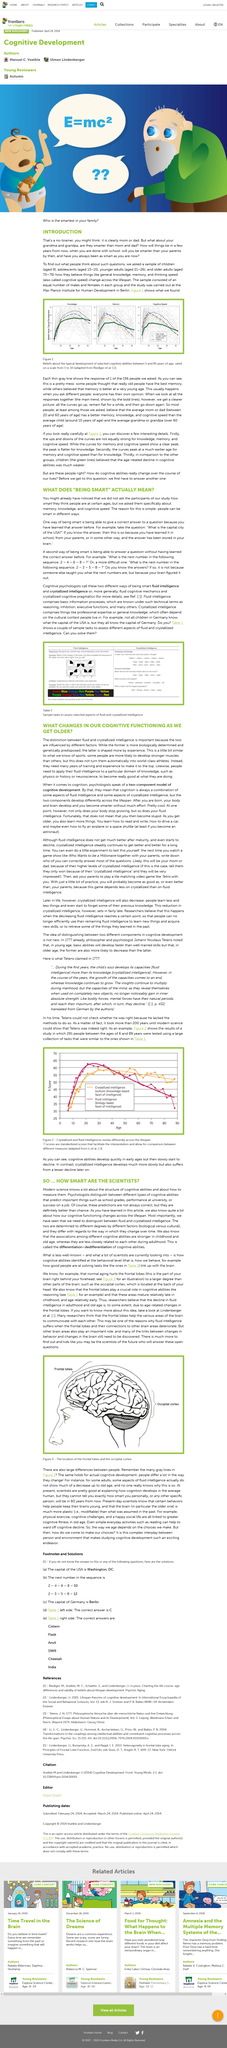Specify some key components in this picture. The main heading in caps lock is called INTRODUCTION. The T-score measures the level of fluid and crystallized intelligence in an individual. Fluid intelligence refers to the ability to reason and solve problems, whereas crystallized intelligence refers to the ability to use knowledge and skills learned in the past to solve new problems. The study asked individuals about memory, knowledge, and cognitive speed. Crystallized intelligence, which consists of professional expertise and general knowledge, is dependent on the cultural context in which people live. The development of fluid and crystallized intelligence was initially suggested by Tetens. 